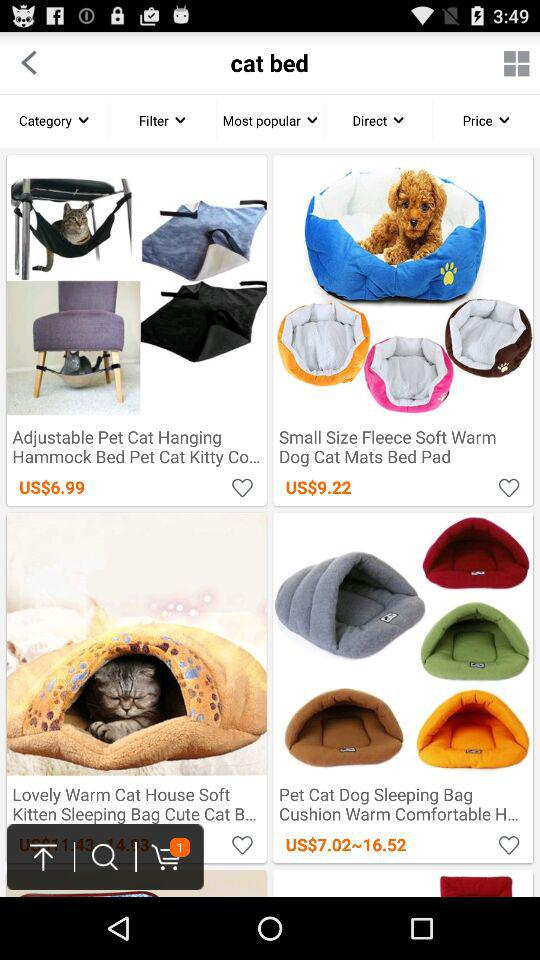What's the price range of "Pet Cat Dog Sleeping Bag Cushion Warm Comfortable"? The price of "Pet Cat Dog Sleeping Bag Cushion Warm Comfortable" ranges from US$7.02 to US$16.52. 